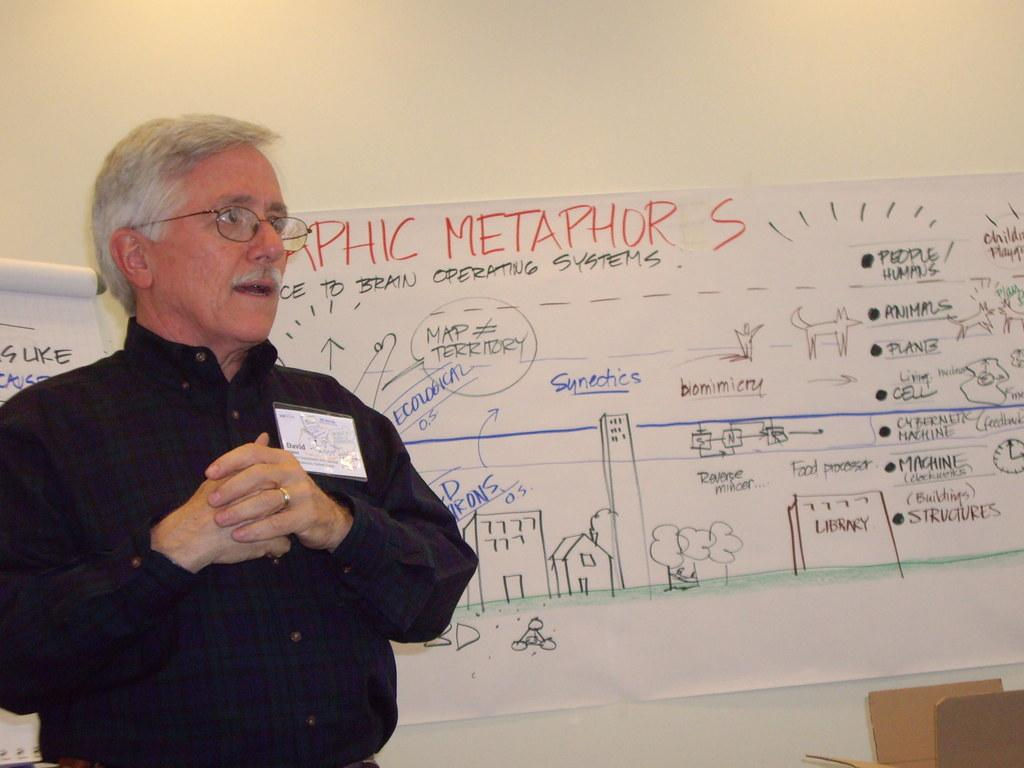<image>
Render a clear and concise summary of the photo. A man stands in front of a big paper that has the word metaphor at the top. 